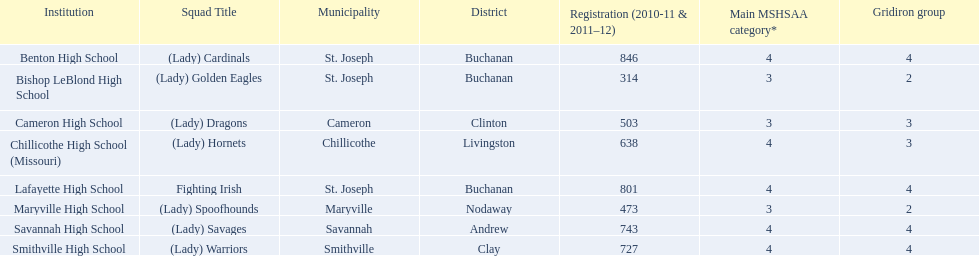What are the names of the schools? Benton High School, Bishop LeBlond High School, Cameron High School, Chillicothe High School (Missouri), Lafayette High School, Maryville High School, Savannah High School, Smithville High School. Can you give me this table in json format? {'header': ['Institution', 'Squad Title', 'Municipality', 'District', 'Registration (2010-11 & 2011–12)', 'Main MSHSAA category*', 'Gridiron group'], 'rows': [['Benton High School', '(Lady) Cardinals', 'St. Joseph', 'Buchanan', '846', '4', '4'], ['Bishop LeBlond High School', '(Lady) Golden Eagles', 'St. Joseph', 'Buchanan', '314', '3', '2'], ['Cameron High School', '(Lady) Dragons', 'Cameron', 'Clinton', '503', '3', '3'], ['Chillicothe High School (Missouri)', '(Lady) Hornets', 'Chillicothe', 'Livingston', '638', '4', '3'], ['Lafayette High School', 'Fighting Irish', 'St. Joseph', 'Buchanan', '801', '4', '4'], ['Maryville High School', '(Lady) Spoofhounds', 'Maryville', 'Nodaway', '473', '3', '2'], ['Savannah High School', '(Lady) Savages', 'Savannah', 'Andrew', '743', '4', '4'], ['Smithville High School', '(Lady) Warriors', 'Smithville', 'Clay', '727', '4', '4']]} Of those, which had a total enrollment of less than 500? Bishop LeBlond High School, Maryville High School. And of those, which had the lowest enrollment? Bishop LeBlond High School. 